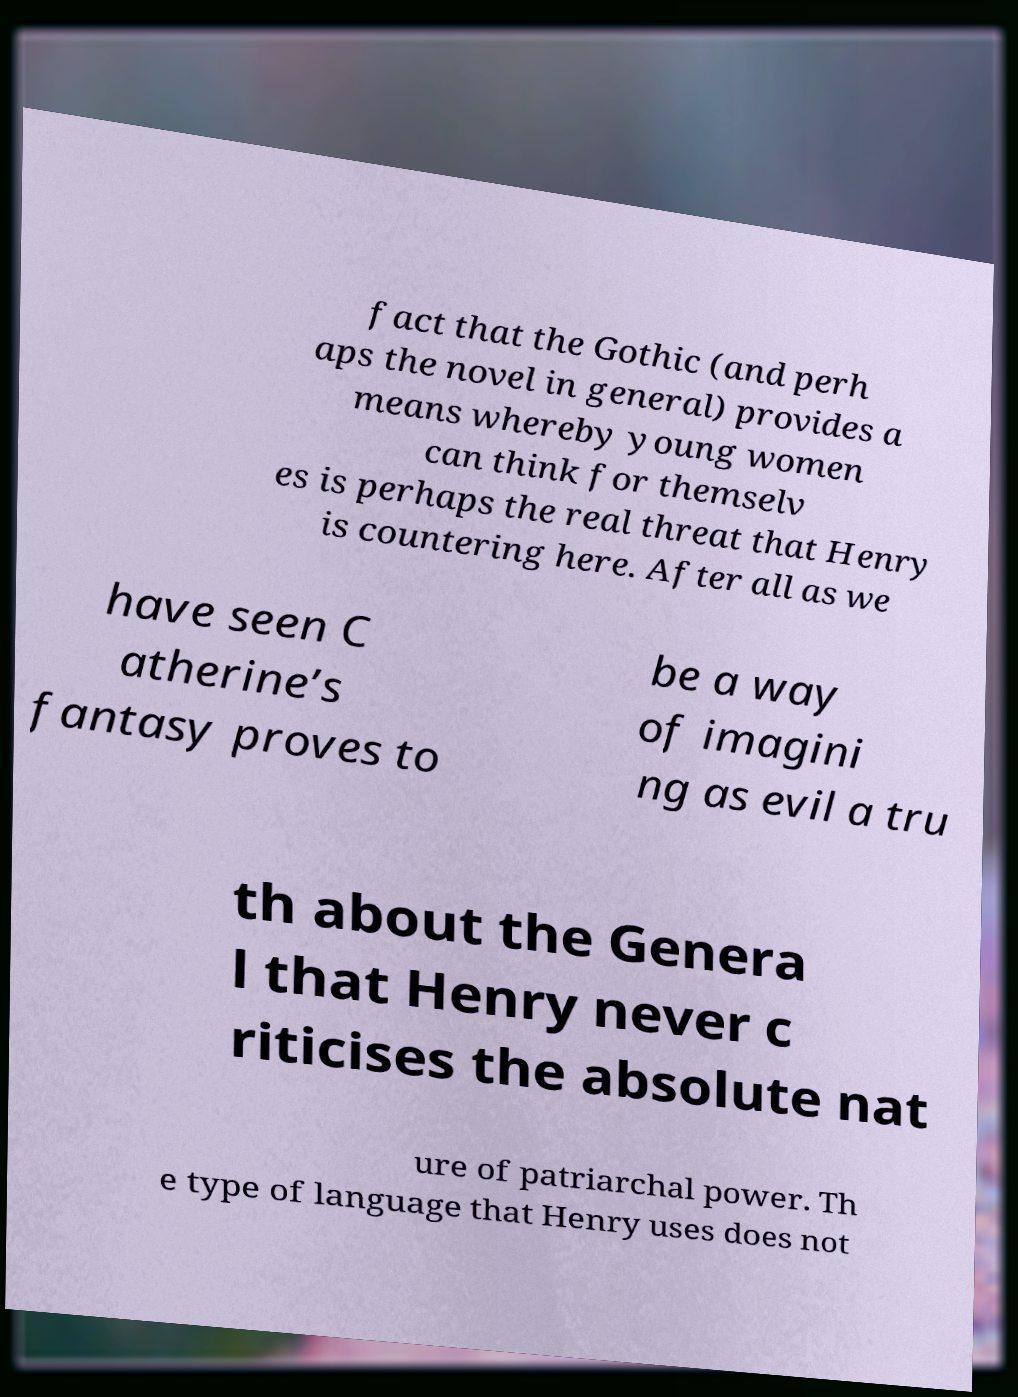Please identify and transcribe the text found in this image. fact that the Gothic (and perh aps the novel in general) provides a means whereby young women can think for themselv es is perhaps the real threat that Henry is countering here. After all as we have seen C atherine’s fantasy proves to be a way of imagini ng as evil a tru th about the Genera l that Henry never c riticises the absolute nat ure of patriarchal power. Th e type of language that Henry uses does not 